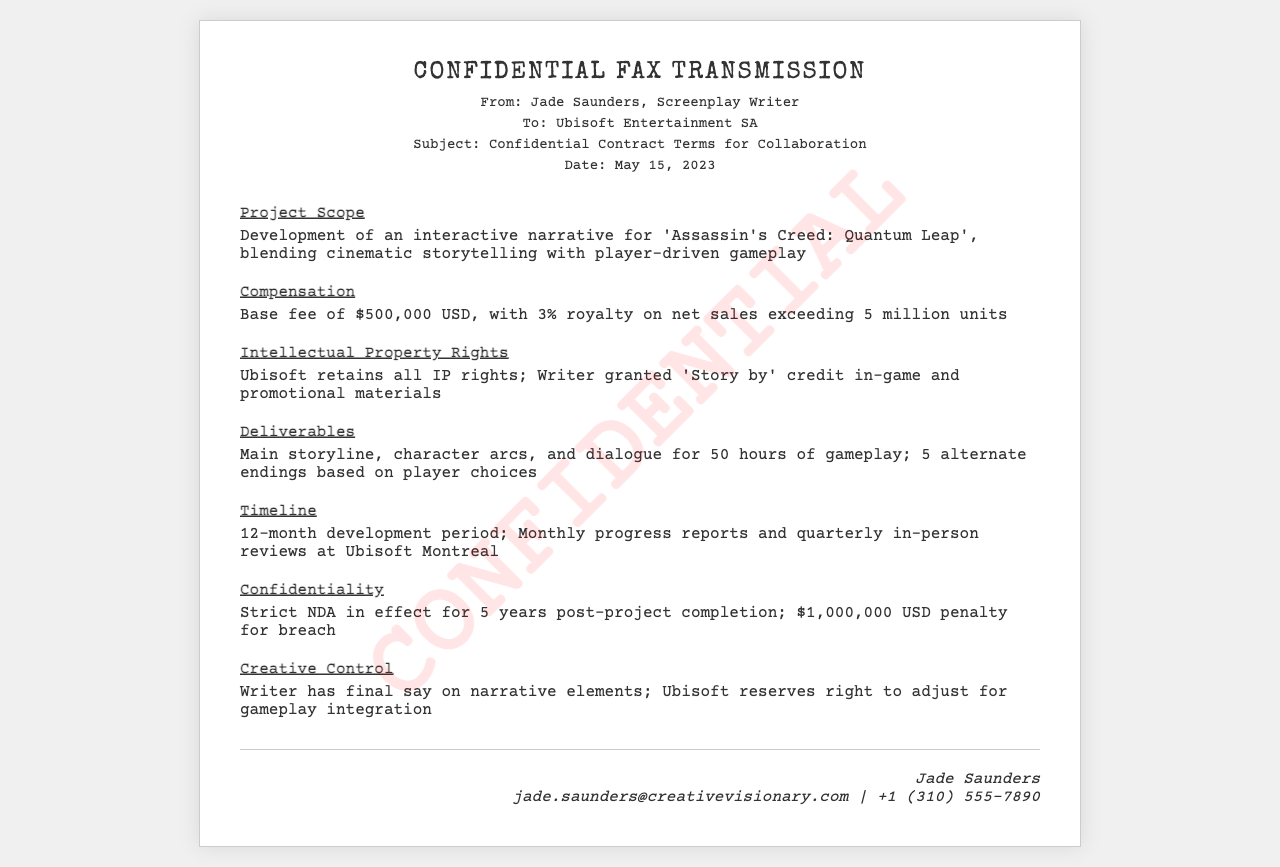what is the project title? The project title is specified in the Project Scope section of the document.
Answer: Assassin's Creed: Quantum Leap what is the base fee for the collaboration? The base fee is mentioned under the Compensation section as the initial amount agreed upon.
Answer: $500,000 USD what percentage of royalty is stipulated on net sales? The percentage of royalty is outlined in the Compensation section which specifies additional earnings from sales.
Answer: 3% how long is the development period? The development period is indicated in the Timeline section outlining the time frame for project completion.
Answer: 12-month what is the penalty amount for breach of confidentiality? The penalty is stated under the Confidentiality section regarding the consequences of breaching the contract.
Answer: $1,000,000 USD who is the author of the fax? The author is identified at the top of the document where the sender's name is provided.
Answer: Jade Saunders how many alternate endings are included in the deliverables? The number of alternate endings is detailed in the Deliverables section that outlines what will be created.
Answer: 5 what kind of reports are required monthly? The type of reports is mentioned in the Timeline section describing communication expectations during development.
Answer: Progress reports what is the purpose of the NDA mentioned? The NDA's purpose is clarified in the Confidentiality section, indicating its role in protecting sensitive information.
Answer: To ensure confidentiality 